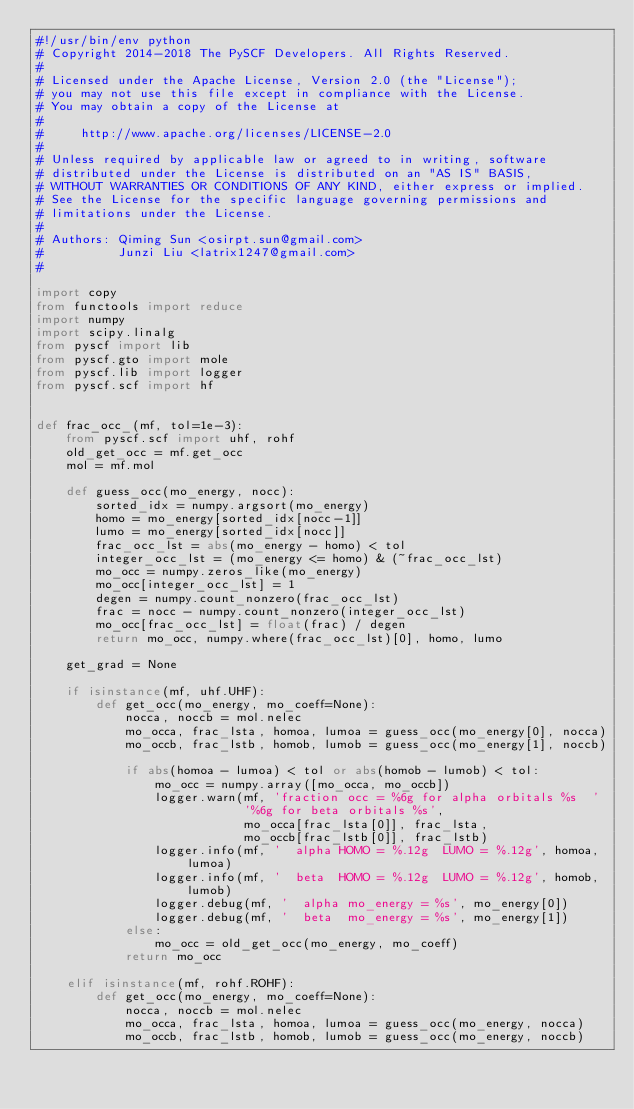Convert code to text. <code><loc_0><loc_0><loc_500><loc_500><_Python_>#!/usr/bin/env python
# Copyright 2014-2018 The PySCF Developers. All Rights Reserved.
#
# Licensed under the Apache License, Version 2.0 (the "License");
# you may not use this file except in compliance with the License.
# You may obtain a copy of the License at
#
#     http://www.apache.org/licenses/LICENSE-2.0
#
# Unless required by applicable law or agreed to in writing, software
# distributed under the License is distributed on an "AS IS" BASIS,
# WITHOUT WARRANTIES OR CONDITIONS OF ANY KIND, either express or implied.
# See the License for the specific language governing permissions and
# limitations under the License.
#
# Authors: Qiming Sun <osirpt.sun@gmail.com>
#          Junzi Liu <latrix1247@gmail.com>
#

import copy
from functools import reduce
import numpy
import scipy.linalg
from pyscf import lib
from pyscf.gto import mole
from pyscf.lib import logger
from pyscf.scf import hf


def frac_occ_(mf, tol=1e-3):
    from pyscf.scf import uhf, rohf
    old_get_occ = mf.get_occ
    mol = mf.mol

    def guess_occ(mo_energy, nocc):
        sorted_idx = numpy.argsort(mo_energy)
        homo = mo_energy[sorted_idx[nocc-1]]
        lumo = mo_energy[sorted_idx[nocc]]
        frac_occ_lst = abs(mo_energy - homo) < tol
        integer_occ_lst = (mo_energy <= homo) & (~frac_occ_lst)
        mo_occ = numpy.zeros_like(mo_energy)
        mo_occ[integer_occ_lst] = 1
        degen = numpy.count_nonzero(frac_occ_lst)
        frac = nocc - numpy.count_nonzero(integer_occ_lst)
        mo_occ[frac_occ_lst] = float(frac) / degen
        return mo_occ, numpy.where(frac_occ_lst)[0], homo, lumo

    get_grad = None

    if isinstance(mf, uhf.UHF):
        def get_occ(mo_energy, mo_coeff=None):
            nocca, noccb = mol.nelec
            mo_occa, frac_lsta, homoa, lumoa = guess_occ(mo_energy[0], nocca)
            mo_occb, frac_lstb, homob, lumob = guess_occ(mo_energy[1], noccb)

            if abs(homoa - lumoa) < tol or abs(homob - lumob) < tol:
                mo_occ = numpy.array([mo_occa, mo_occb])
                logger.warn(mf, 'fraction occ = %6g for alpha orbitals %s  '
                            '%6g for beta orbitals %s',
                            mo_occa[frac_lsta[0]], frac_lsta,
                            mo_occb[frac_lstb[0]], frac_lstb)
                logger.info(mf, '  alpha HOMO = %.12g  LUMO = %.12g', homoa, lumoa)
                logger.info(mf, '  beta  HOMO = %.12g  LUMO = %.12g', homob, lumob)
                logger.debug(mf, '  alpha mo_energy = %s', mo_energy[0])
                logger.debug(mf, '  beta  mo_energy = %s', mo_energy[1])
            else:
                mo_occ = old_get_occ(mo_energy, mo_coeff)
            return mo_occ

    elif isinstance(mf, rohf.ROHF):
        def get_occ(mo_energy, mo_coeff=None):
            nocca, noccb = mol.nelec
            mo_occa, frac_lsta, homoa, lumoa = guess_occ(mo_energy, nocca)
            mo_occb, frac_lstb, homob, lumob = guess_occ(mo_energy, noccb)
</code> 